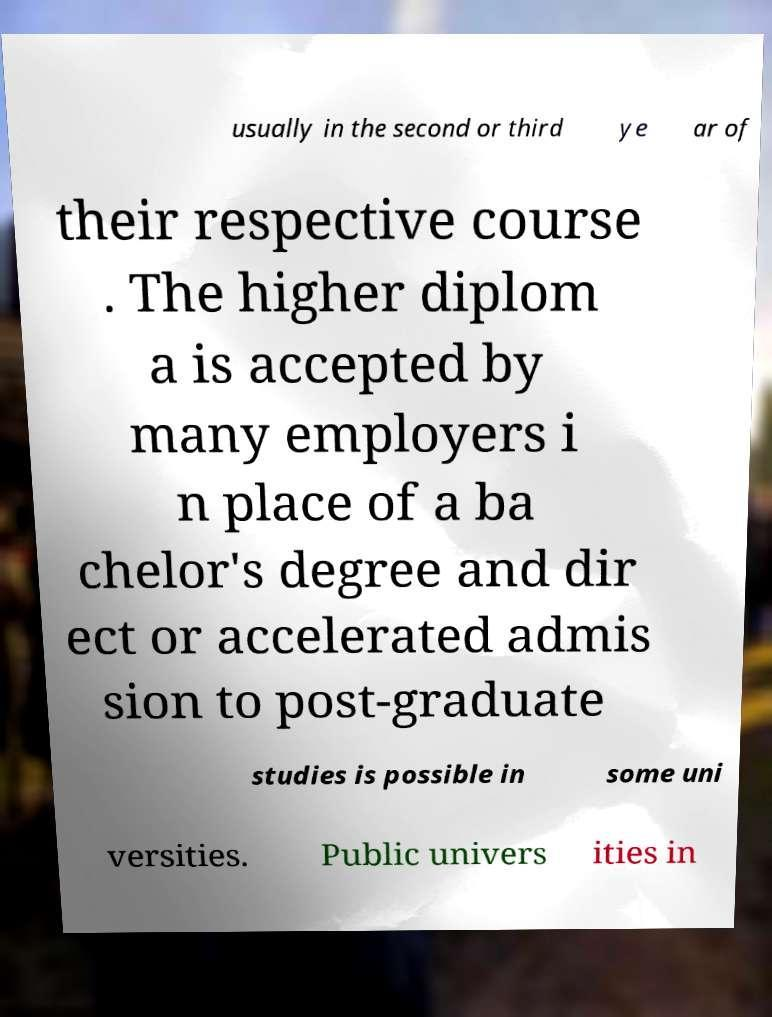Please read and relay the text visible in this image. What does it say? usually in the second or third ye ar of their respective course . The higher diplom a is accepted by many employers i n place of a ba chelor's degree and dir ect or accelerated admis sion to post-graduate studies is possible in some uni versities. Public univers ities in 